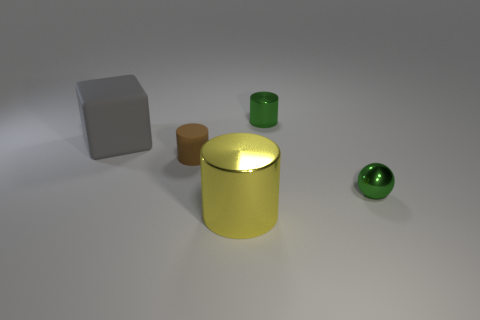Subtract all small cylinders. How many cylinders are left? 1 Subtract 1 cylinders. How many cylinders are left? 2 Add 4 small green balls. How many objects exist? 9 Add 2 small green objects. How many small green objects exist? 4 Subtract 0 purple blocks. How many objects are left? 5 Subtract all balls. How many objects are left? 4 Subtract all red cylinders. Subtract all brown balls. How many cylinders are left? 3 Subtract all gray cylinders. How many red spheres are left? 0 Subtract all tiny spheres. Subtract all small rubber cylinders. How many objects are left? 3 Add 1 tiny shiny balls. How many tiny shiny balls are left? 2 